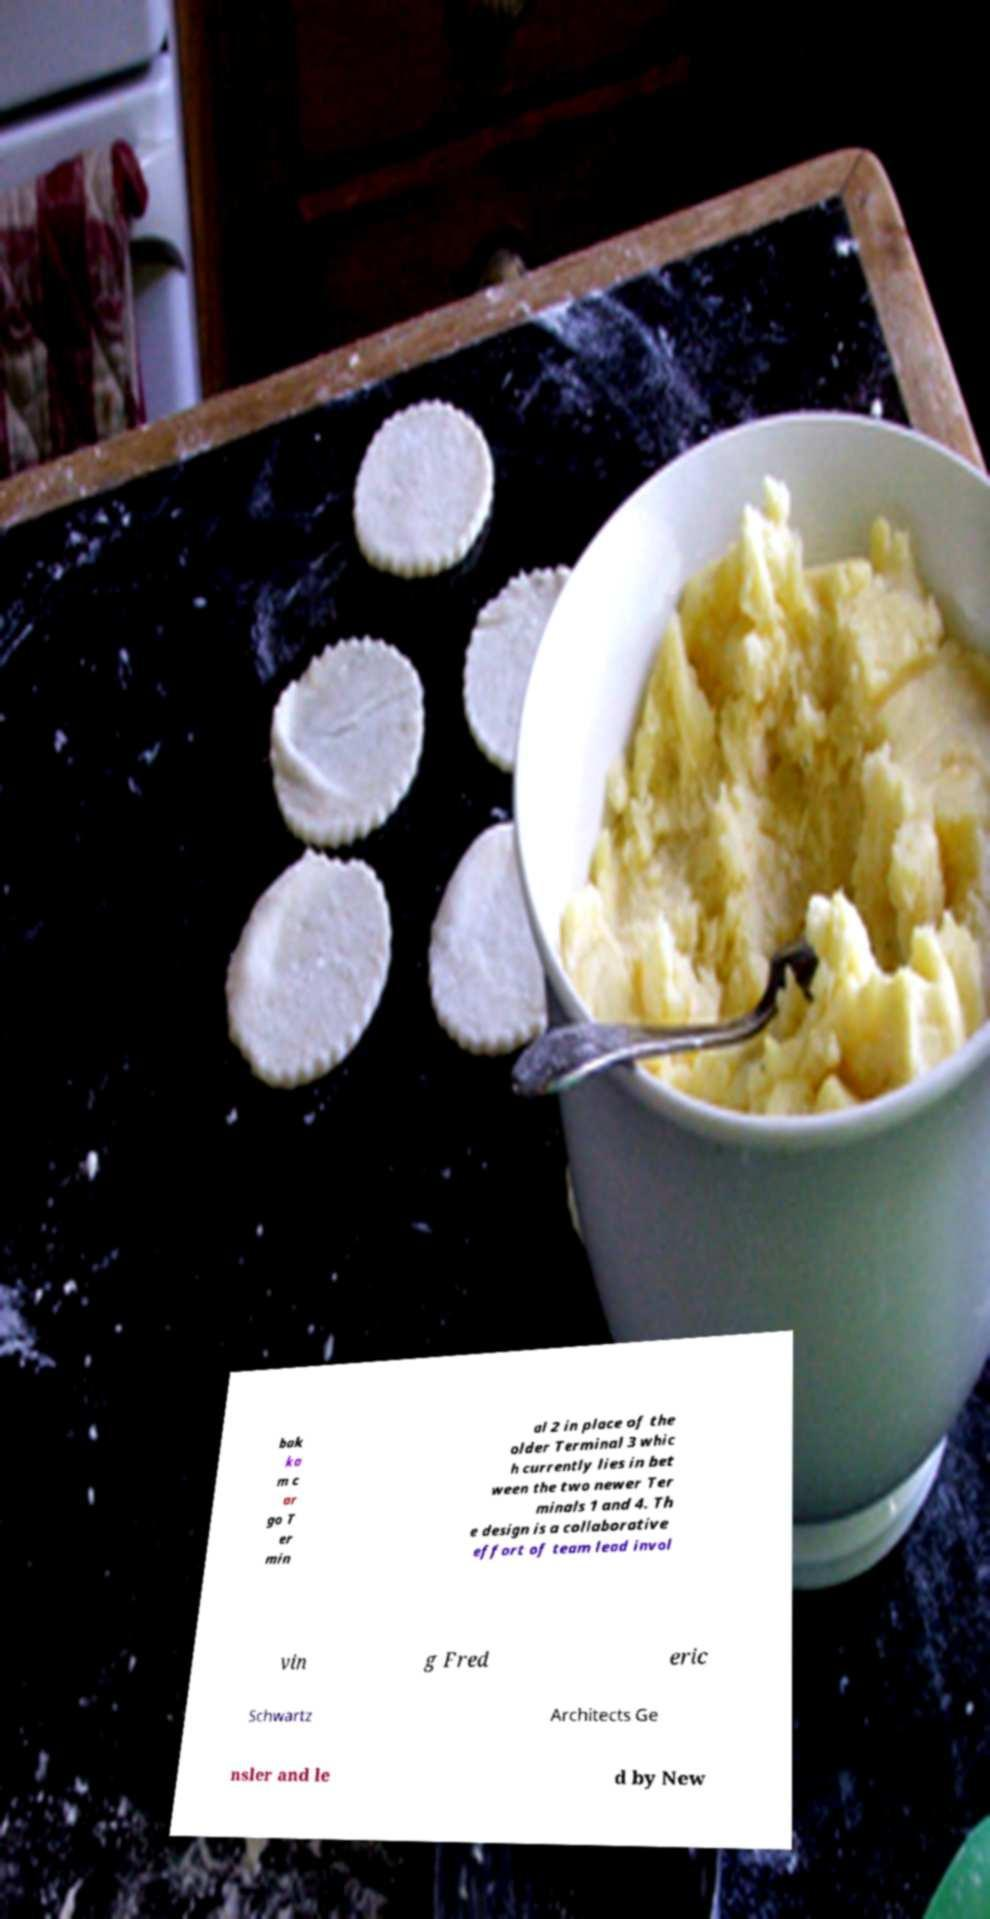Can you read and provide the text displayed in the image?This photo seems to have some interesting text. Can you extract and type it out for me? bak ka m c ar go T er min al 2 in place of the older Terminal 3 whic h currently lies in bet ween the two newer Ter minals 1 and 4. Th e design is a collaborative effort of team lead invol vin g Fred eric Schwartz Architects Ge nsler and le d by New 